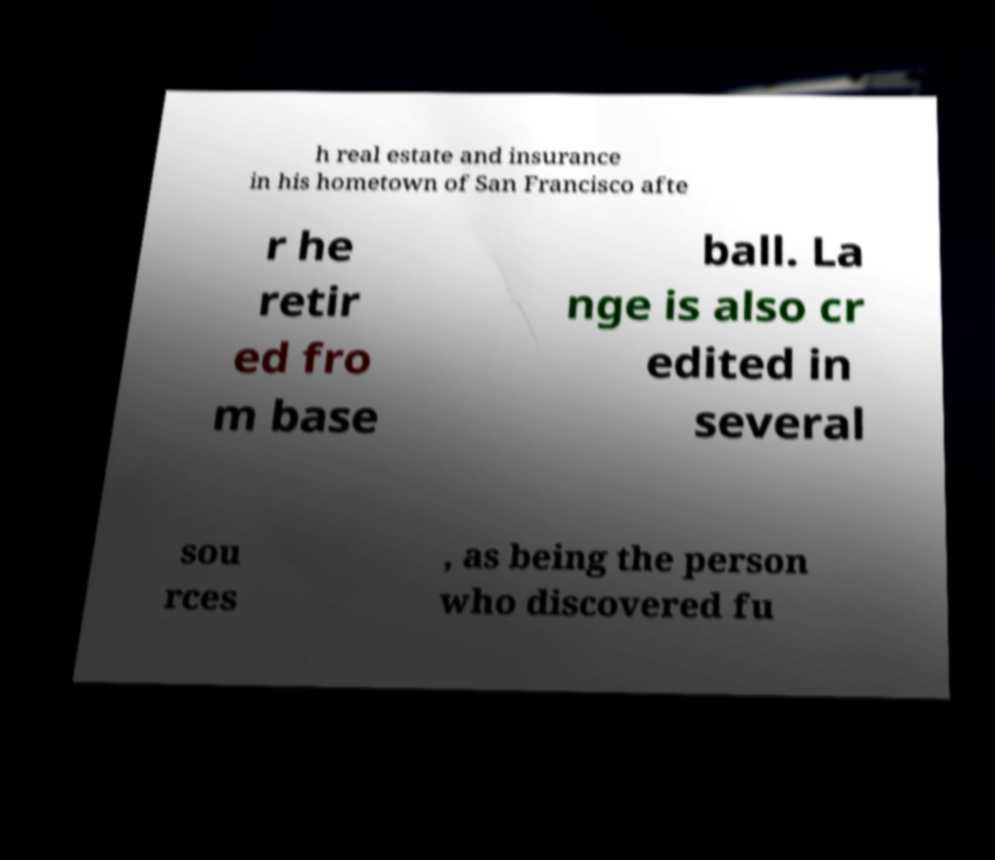For documentation purposes, I need the text within this image transcribed. Could you provide that? h real estate and insurance in his hometown of San Francisco afte r he retir ed fro m base ball. La nge is also cr edited in several sou rces , as being the person who discovered fu 